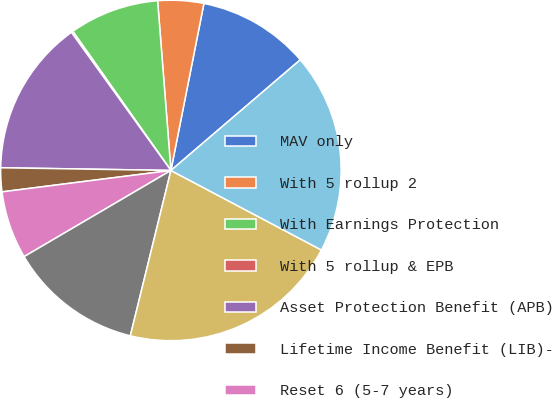Convert chart. <chart><loc_0><loc_0><loc_500><loc_500><pie_chart><fcel>MAV only<fcel>With 5 rollup 2<fcel>With Earnings Protection<fcel>With 5 rollup & EPB<fcel>Asset Protection Benefit (APB)<fcel>Lifetime Income Benefit (LIB)-<fcel>Reset 6 (5-7 years)<fcel>Return of Premium (ROP)<fcel>Subtotal US GMDB<fcel>Japan GMDB 9 11<nl><fcel>10.63%<fcel>4.35%<fcel>8.53%<fcel>0.16%<fcel>14.81%<fcel>2.26%<fcel>6.44%<fcel>12.72%<fcel>21.09%<fcel>19.0%<nl></chart> 